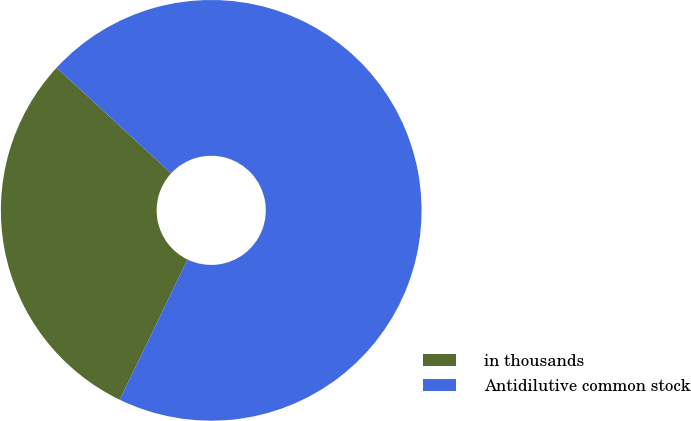Convert chart to OTSL. <chart><loc_0><loc_0><loc_500><loc_500><pie_chart><fcel>in thousands<fcel>Antidilutive common stock<nl><fcel>29.7%<fcel>70.3%<nl></chart> 